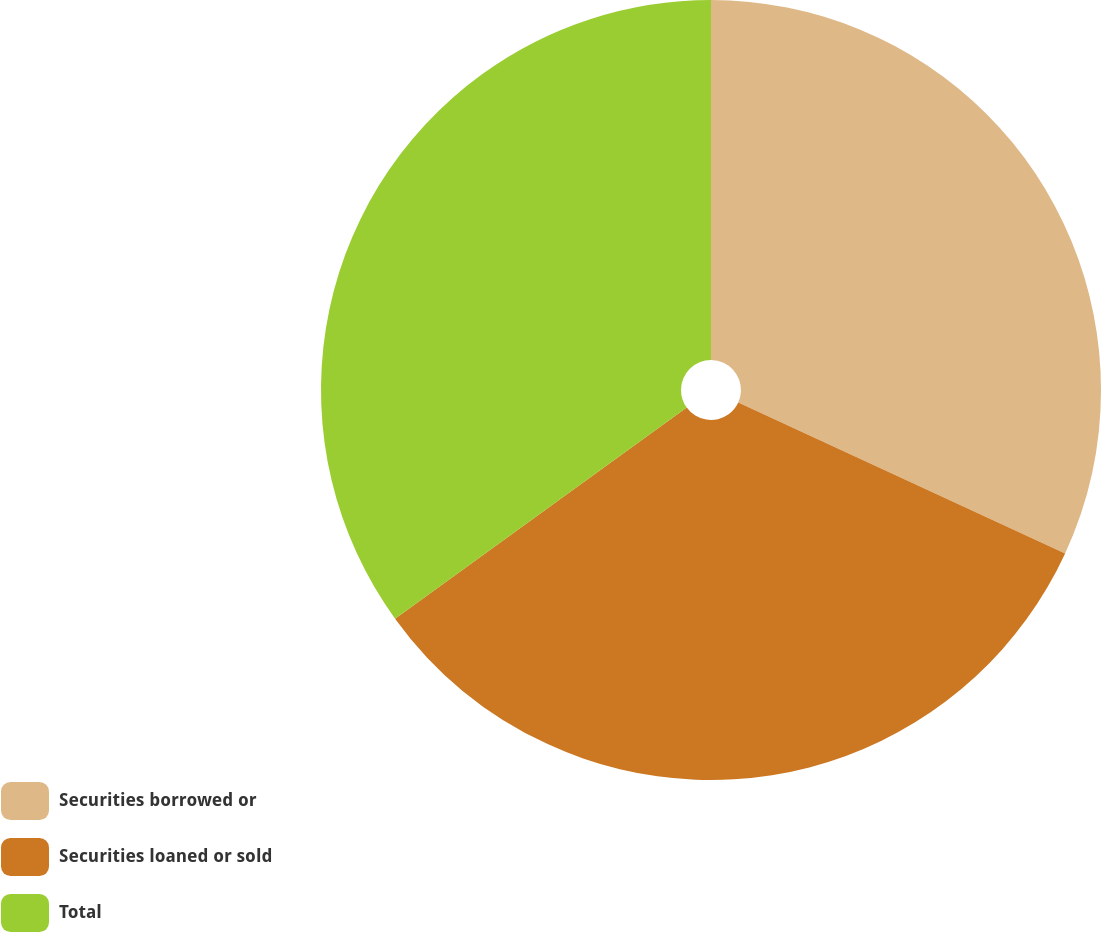<chart> <loc_0><loc_0><loc_500><loc_500><pie_chart><fcel>Securities borrowed or<fcel>Securities loaned or sold<fcel>Total<nl><fcel>31.88%<fcel>33.15%<fcel>34.97%<nl></chart> 